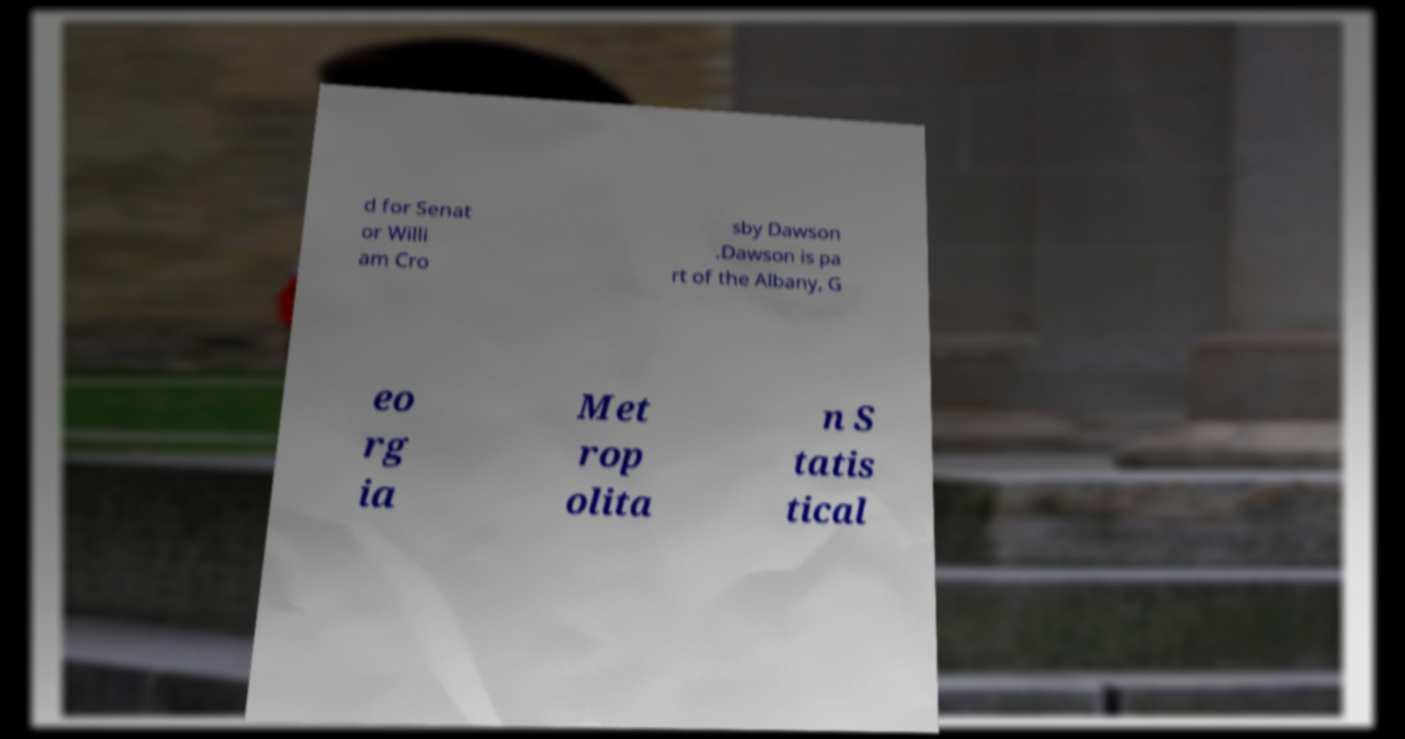Can you accurately transcribe the text from the provided image for me? d for Senat or Willi am Cro sby Dawson .Dawson is pa rt of the Albany, G eo rg ia Met rop olita n S tatis tical 